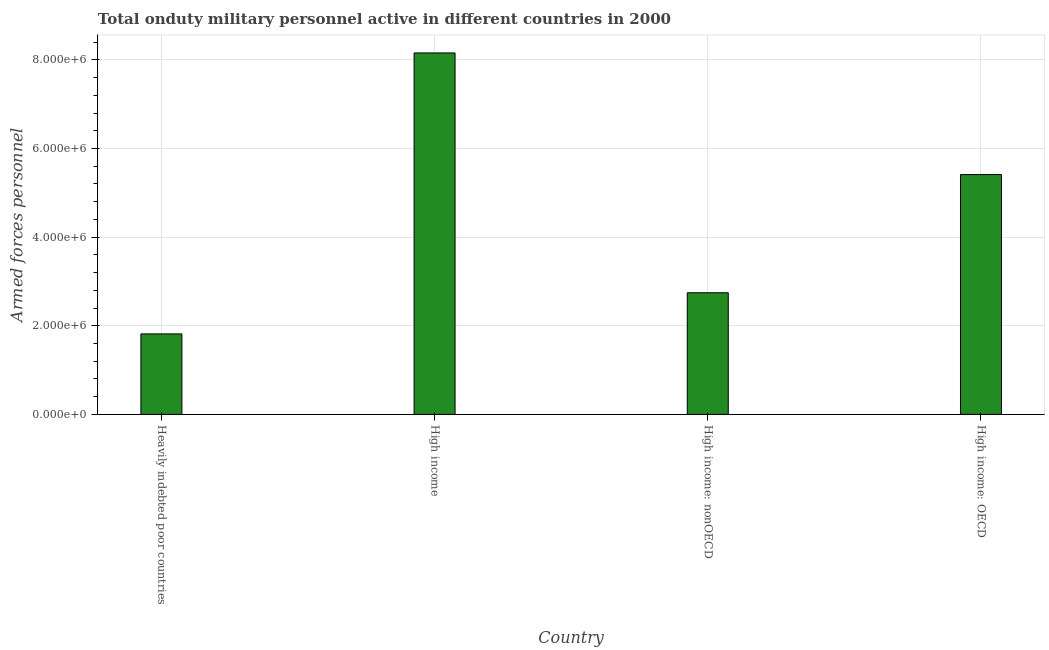Does the graph contain grids?
Provide a succinct answer. Yes. What is the title of the graph?
Provide a succinct answer. Total onduty military personnel active in different countries in 2000. What is the label or title of the Y-axis?
Provide a succinct answer. Armed forces personnel. What is the number of armed forces personnel in High income: OECD?
Your answer should be compact. 5.41e+06. Across all countries, what is the maximum number of armed forces personnel?
Offer a very short reply. 8.16e+06. Across all countries, what is the minimum number of armed forces personnel?
Ensure brevity in your answer.  1.82e+06. In which country was the number of armed forces personnel maximum?
Your answer should be compact. High income. In which country was the number of armed forces personnel minimum?
Your answer should be very brief. Heavily indebted poor countries. What is the sum of the number of armed forces personnel?
Provide a short and direct response. 1.81e+07. What is the difference between the number of armed forces personnel in Heavily indebted poor countries and High income: OECD?
Your answer should be compact. -3.59e+06. What is the average number of armed forces personnel per country?
Your answer should be very brief. 4.53e+06. What is the median number of armed forces personnel?
Provide a short and direct response. 4.08e+06. What is the ratio of the number of armed forces personnel in Heavily indebted poor countries to that in High income?
Make the answer very short. 0.22. Is the number of armed forces personnel in High income less than that in High income: OECD?
Ensure brevity in your answer.  No. What is the difference between the highest and the second highest number of armed forces personnel?
Make the answer very short. 2.74e+06. Is the sum of the number of armed forces personnel in Heavily indebted poor countries and High income greater than the maximum number of armed forces personnel across all countries?
Your answer should be very brief. Yes. What is the difference between the highest and the lowest number of armed forces personnel?
Your answer should be compact. 6.34e+06. In how many countries, is the number of armed forces personnel greater than the average number of armed forces personnel taken over all countries?
Your answer should be very brief. 2. Are the values on the major ticks of Y-axis written in scientific E-notation?
Make the answer very short. Yes. What is the Armed forces personnel in Heavily indebted poor countries?
Provide a short and direct response. 1.82e+06. What is the Armed forces personnel of High income?
Your answer should be compact. 8.16e+06. What is the Armed forces personnel in High income: nonOECD?
Your response must be concise. 2.74e+06. What is the Armed forces personnel in High income: OECD?
Make the answer very short. 5.41e+06. What is the difference between the Armed forces personnel in Heavily indebted poor countries and High income?
Offer a very short reply. -6.34e+06. What is the difference between the Armed forces personnel in Heavily indebted poor countries and High income: nonOECD?
Your response must be concise. -9.28e+05. What is the difference between the Armed forces personnel in Heavily indebted poor countries and High income: OECD?
Your response must be concise. -3.59e+06. What is the difference between the Armed forces personnel in High income and High income: nonOECD?
Give a very brief answer. 5.41e+06. What is the difference between the Armed forces personnel in High income and High income: OECD?
Your answer should be very brief. 2.74e+06. What is the difference between the Armed forces personnel in High income: nonOECD and High income: OECD?
Your answer should be compact. -2.67e+06. What is the ratio of the Armed forces personnel in Heavily indebted poor countries to that in High income?
Make the answer very short. 0.22. What is the ratio of the Armed forces personnel in Heavily indebted poor countries to that in High income: nonOECD?
Your answer should be very brief. 0.66. What is the ratio of the Armed forces personnel in Heavily indebted poor countries to that in High income: OECD?
Ensure brevity in your answer.  0.34. What is the ratio of the Armed forces personnel in High income to that in High income: nonOECD?
Offer a very short reply. 2.97. What is the ratio of the Armed forces personnel in High income to that in High income: OECD?
Provide a succinct answer. 1.51. What is the ratio of the Armed forces personnel in High income: nonOECD to that in High income: OECD?
Make the answer very short. 0.51. 